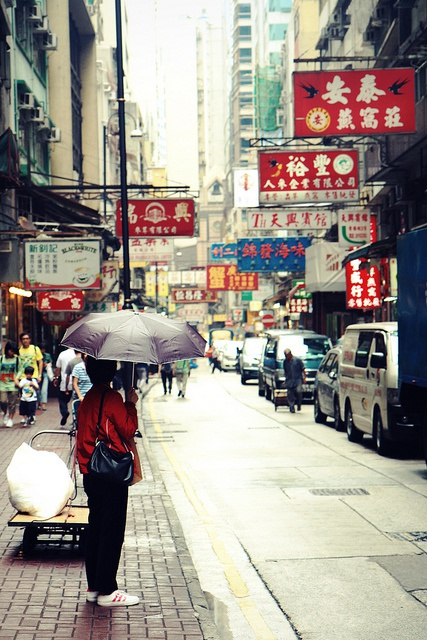Describe the objects in this image and their specific colors. I can see people in black, maroon, brown, and beige tones, car in black, gray, and darkgray tones, umbrella in black, darkgray, beige, gray, and lightgray tones, car in black, ivory, darkgray, and gray tones, and car in black, gray, and darkgray tones in this image. 